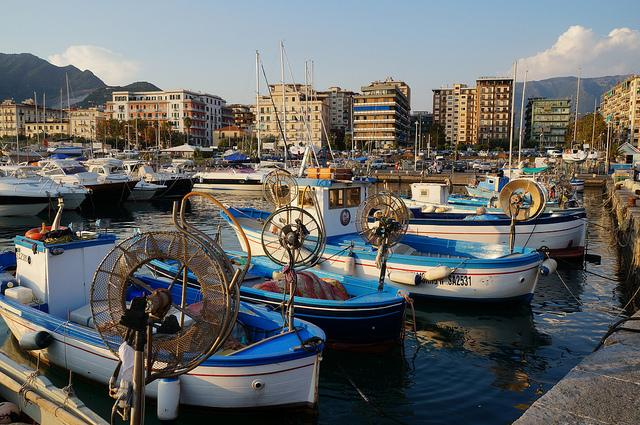What would this location be called? Please explain your reasoning. dock. The boats are docked at the port. 